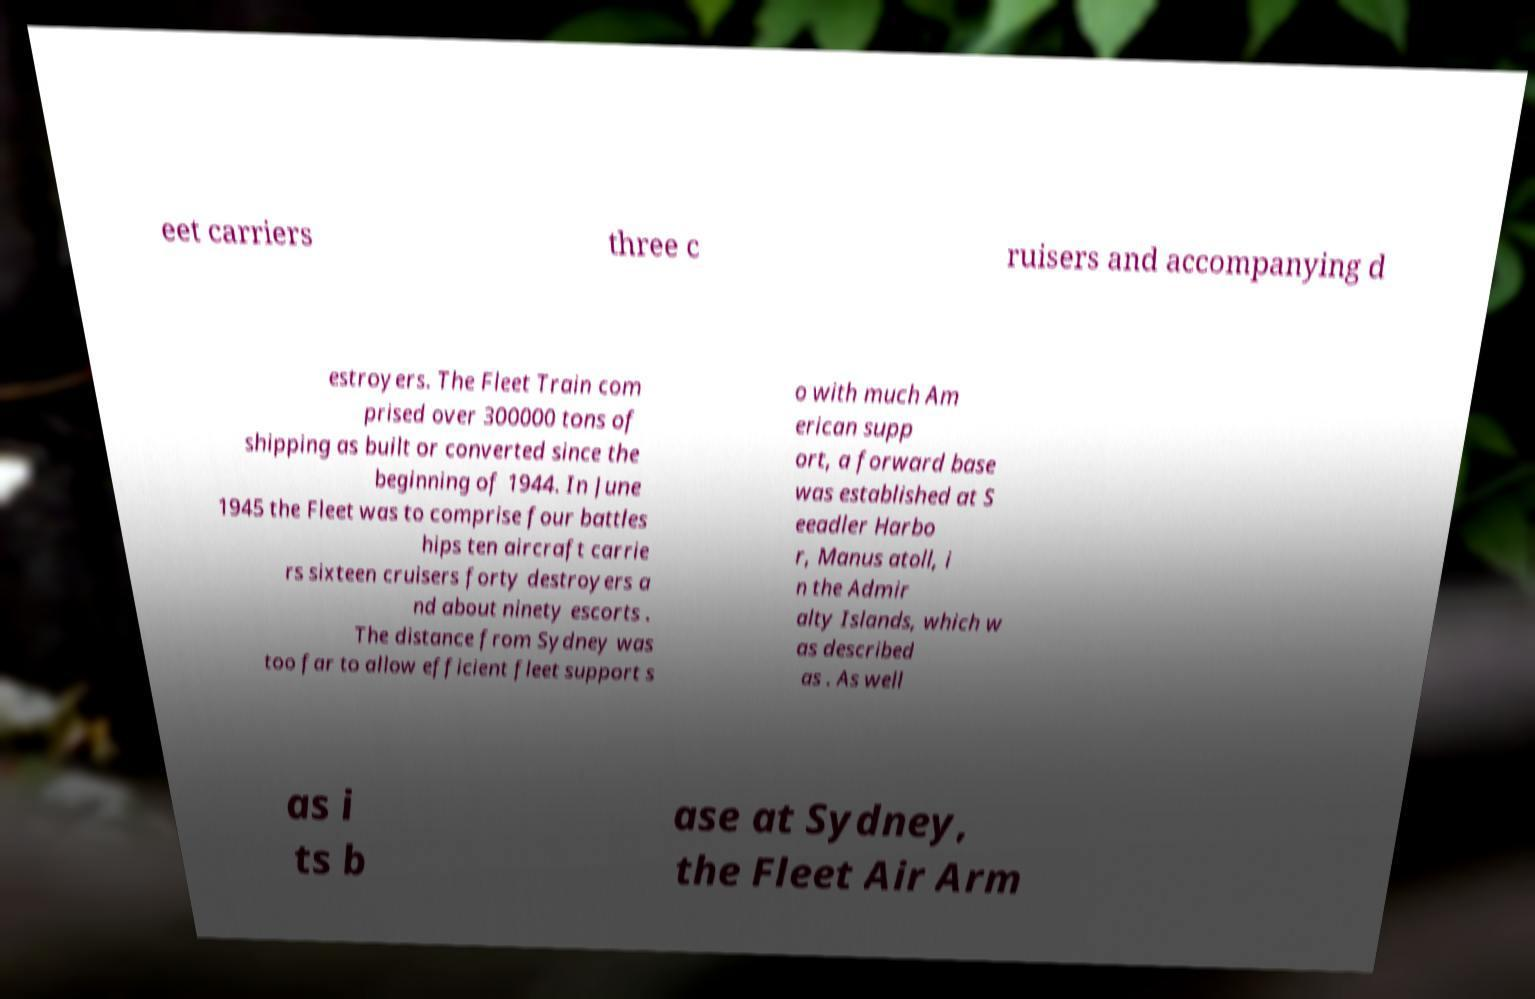Could you extract and type out the text from this image? eet carriers three c ruisers and accompanying d estroyers. The Fleet Train com prised over 300000 tons of shipping as built or converted since the beginning of 1944. In June 1945 the Fleet was to comprise four battles hips ten aircraft carrie rs sixteen cruisers forty destroyers a nd about ninety escorts . The distance from Sydney was too far to allow efficient fleet support s o with much Am erican supp ort, a forward base was established at S eeadler Harbo r, Manus atoll, i n the Admir alty Islands, which w as described as . As well as i ts b ase at Sydney, the Fleet Air Arm 